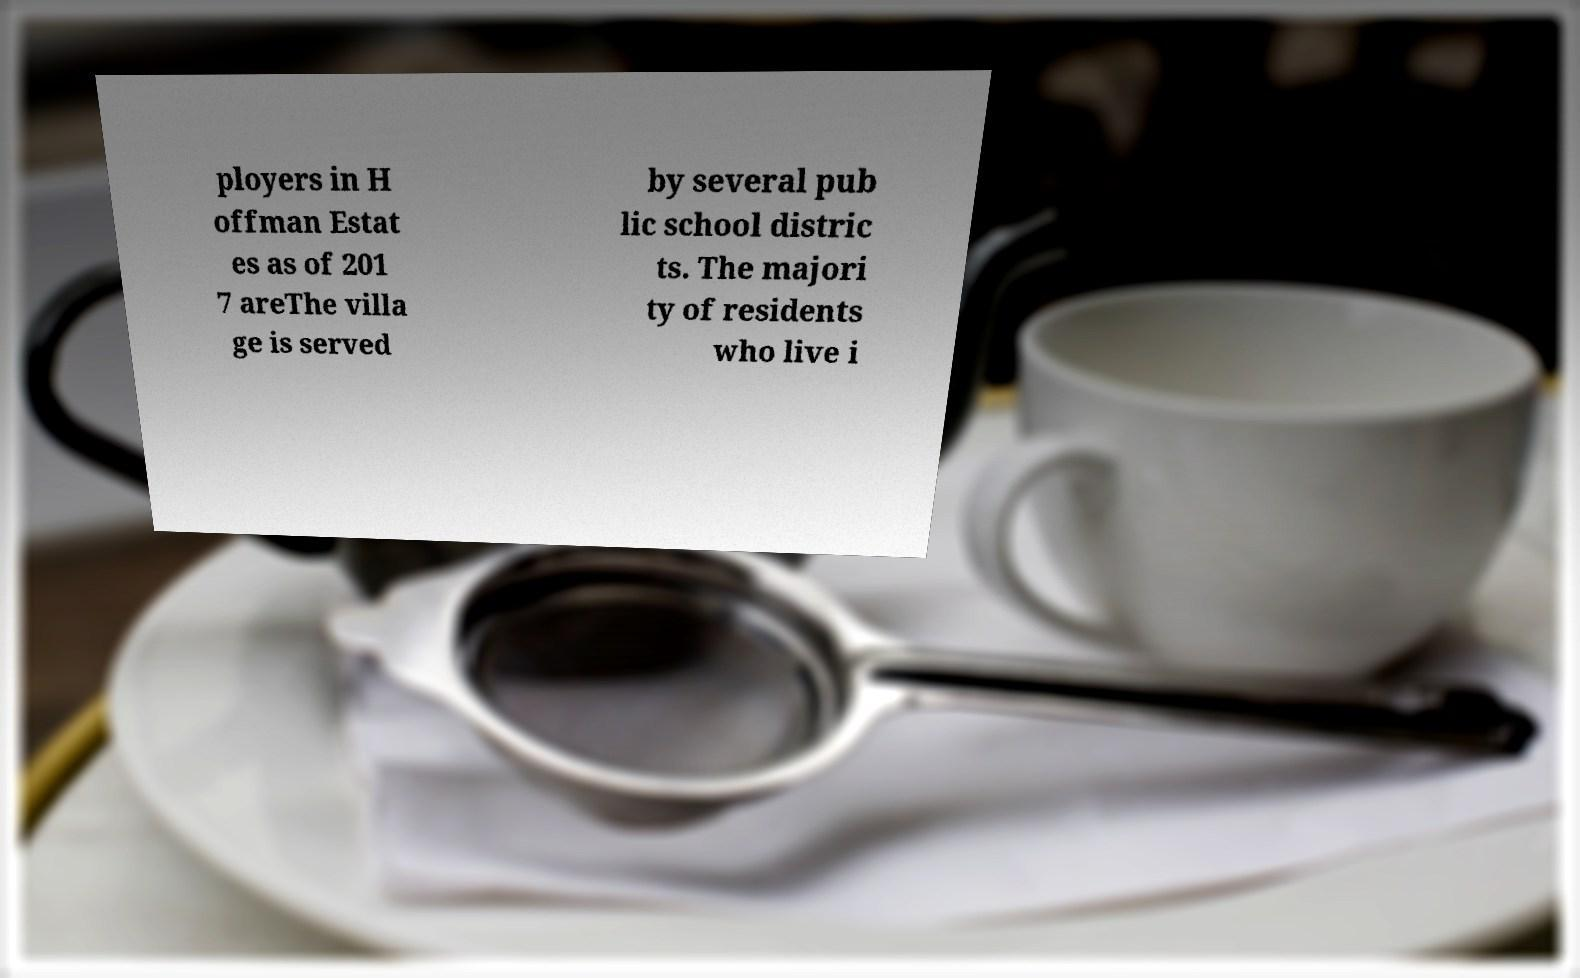Can you read and provide the text displayed in the image?This photo seems to have some interesting text. Can you extract and type it out for me? ployers in H offman Estat es as of 201 7 areThe villa ge is served by several pub lic school distric ts. The majori ty of residents who live i 